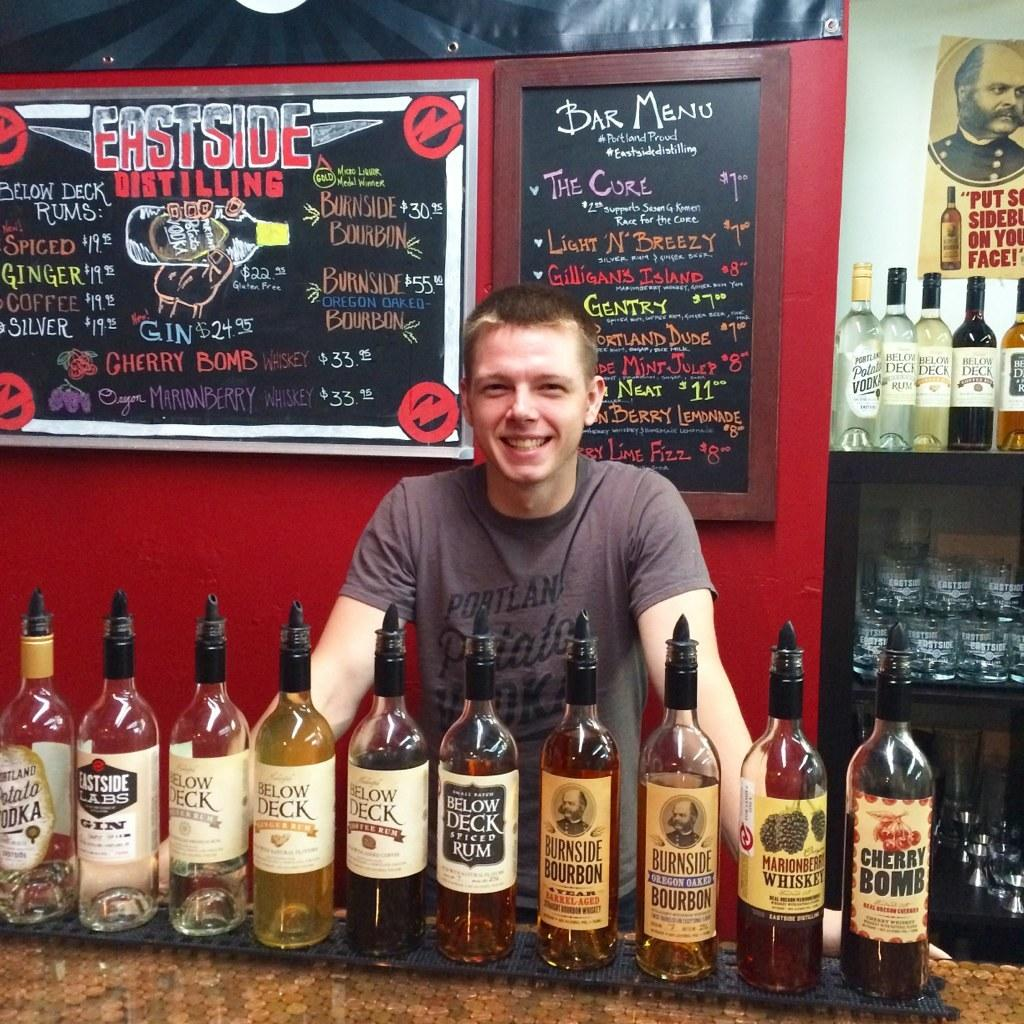Provide a one-sentence caption for the provided image. A man standing at East Side Distilling with liquor in bottles. 